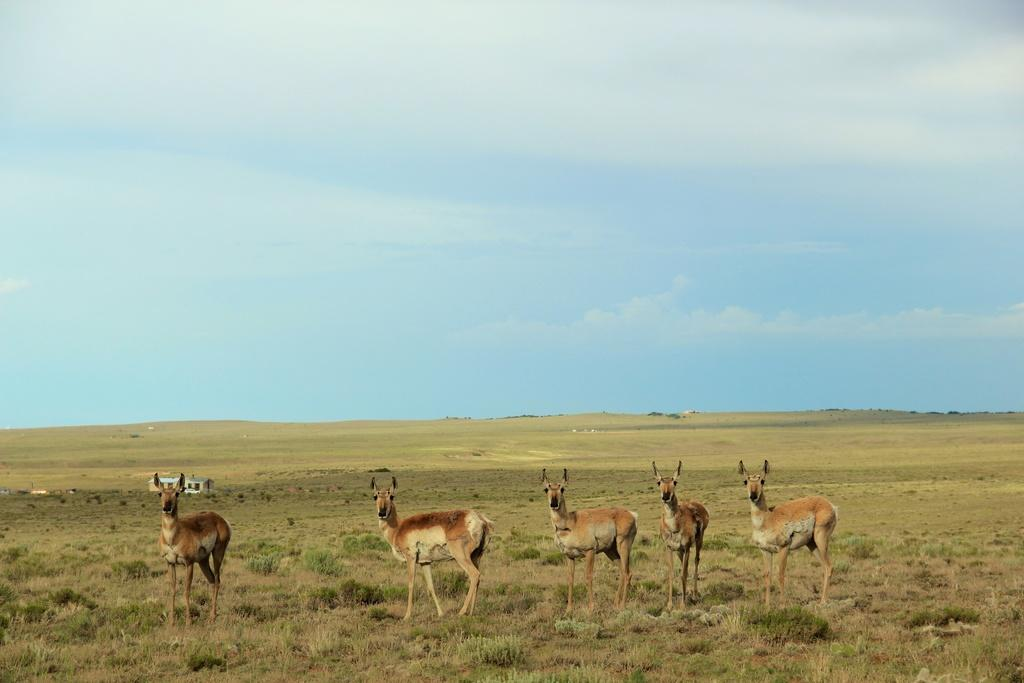What type of animals can be seen in the image? There is a herd of animals in the image. What is the ground surface like where the animals are standing? The animals are standing on grass. What type of structure is visible in the image? There is a shed in the image. What is visible in the background of the image? The sky is visible in the image, and clouds are present in the sky. What type of jewel is being used to skate by the animals in the image? There is no jewel or skate present in the image; it features a herd of animals standing on grass with a shed in the background. 